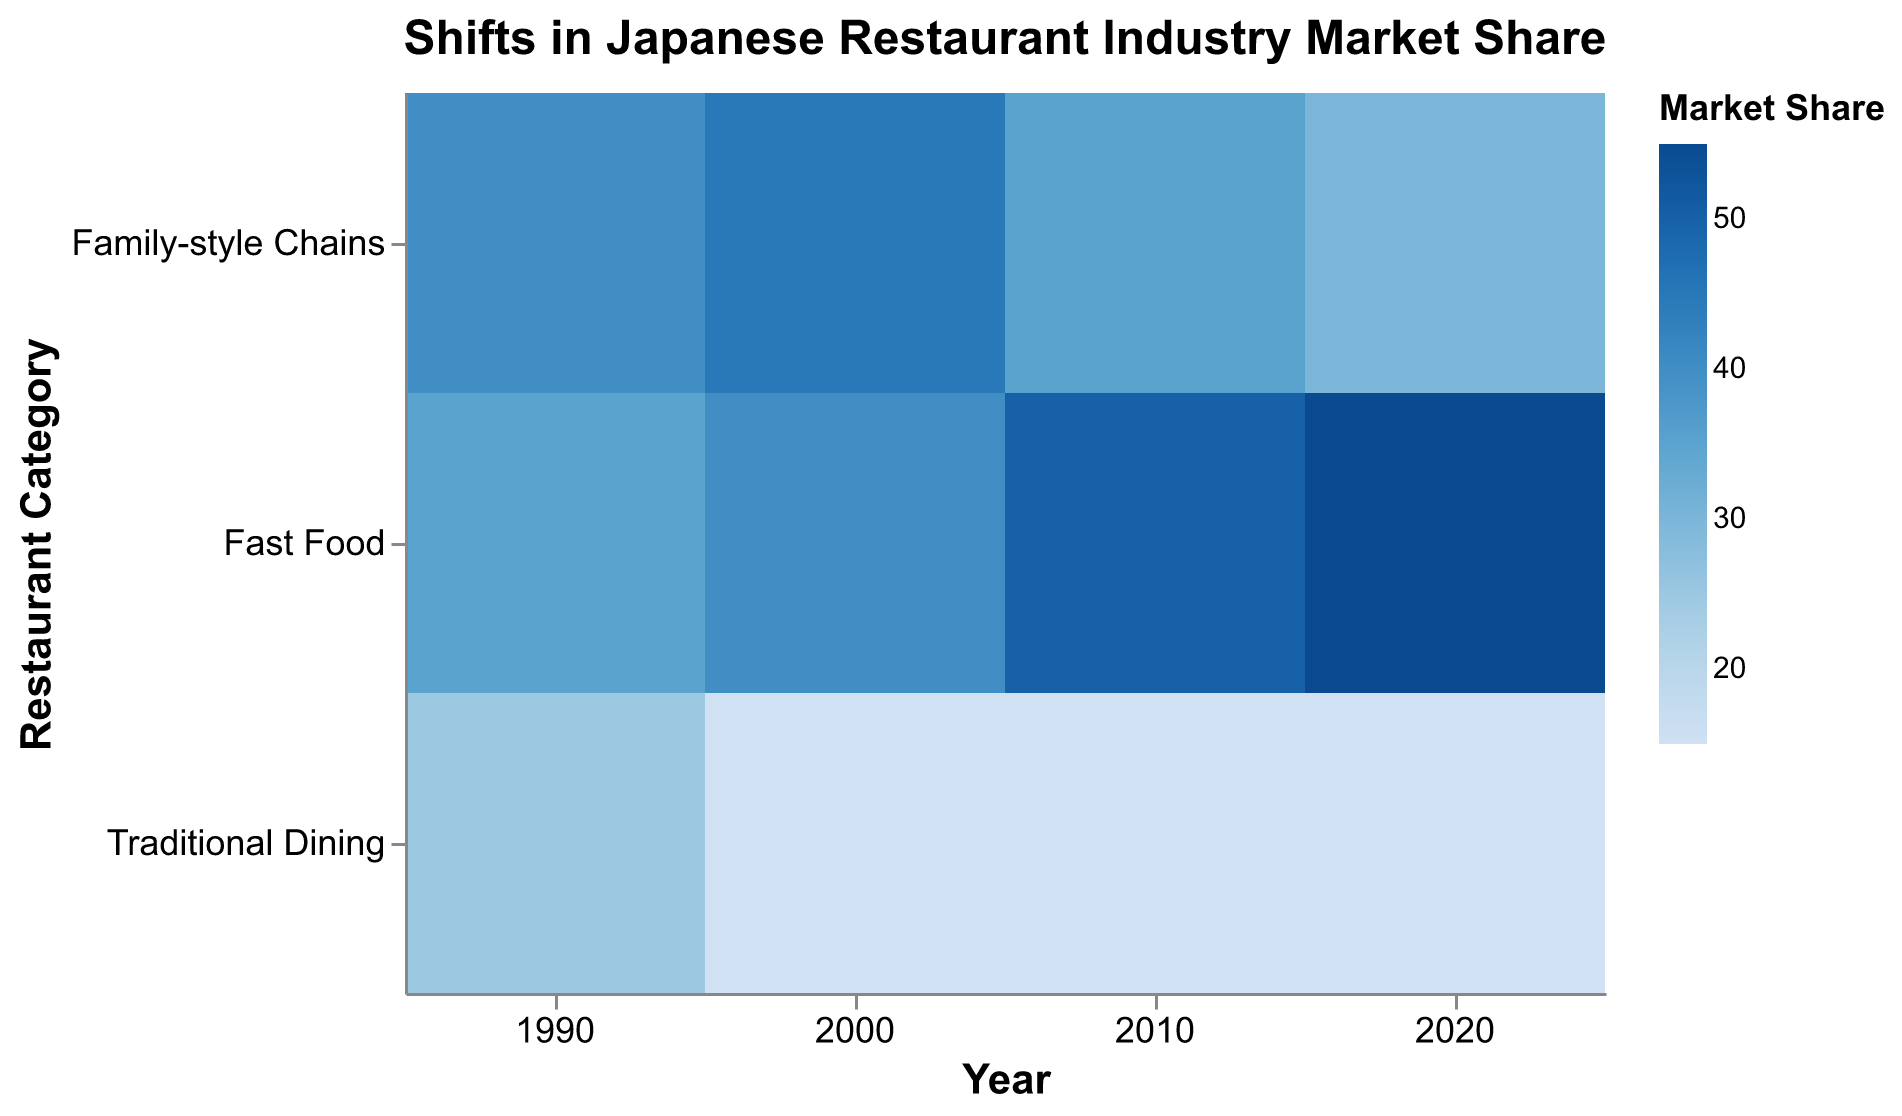What is the title of the figure? The title is prominently placed at the top of the figure. It reads, "Shifts in Japanese Restaurant Industry Market Share."
Answer: "Shifts in Japanese Restaurant Industry Market Share" Which year had the highest market share for Family-style Chains? By examining the color intensity for Family-style Chains across the years, the darkest segment indicates the highest market share. The year 2000 has the darkest blue color for Family-style Chains.
Answer: 2000 What was the market share of Traditional Dining in 1990? Referring to the tooltip or the color intensity, the market share for Traditional Dining in 1990 is listed as part of the chart.
Answer: 25% Between which years did the Fast Food category experience the largest increase in market share? By comparing market shares visually across the years, the largest change is observed between 2000 and 2010, where the share increased from 40% to 50%.
Answer: 2000 to 2010 How does the market share of Family-style Chains in 2020 compare to 1990? Family-style Chains had a 40% market share in 1990 and a 30% market share in 2020. They saw a decrease of 10% over this period.
Answer: Decreased by 10% In which year did the Traditional Dining category maintain a constant market share? Traditional Dining maintained a constant share of 15% between 2000, 2010, and 2020.
Answer: 2000, 2010, and 2020 What is the total market share percentage change for Fast Food from 1990 to 2020? Fast Food's market share was 35% in 1990 and 55% in 2020. The change can be calculated as 55% - 35% = 20%.
Answer: Increased by 20% Which restaurant category consistently had the lowest market share from 2000 onwards? By observing the color intensity and comparing values, Traditional Dining consistently had the lowest market share at 15% from 2000 onwards.
Answer: Traditional Dining How did the market share distribution among the three categories change from 1990 to 2020? In 1990, Family-style Chains had 40%, Fast Food had 35%, and Traditional Dining had 25%. By 2020, Family-style Chains dropped to 30%, Fast Food increased to 55%, and Traditional Dining decreased to 15%. This shows a shift where Fast Food gained a larger share while the other two categories lost share.
Answer: Family-style Chains: Decreased, Fast Food: Increased, Traditional Dining: Decreased What trend can be observed for the Family-style Chains from 2000 to 2020? The market share of Family-style Chains decreased from 45% in 2000 to 35% in 2010 and then to 30% in 2020, indicating a downward trend.
Answer: Downward trend 